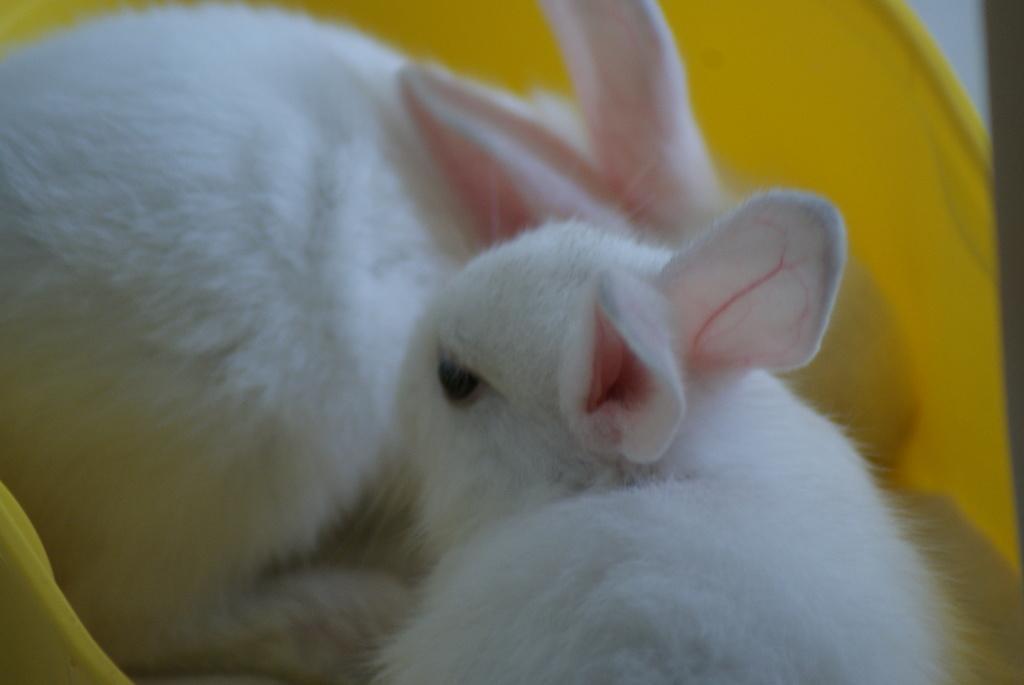Can you describe this image briefly? In this image I can see a yellow colored object and in the yellow colored object I can see two rabbits which are white, black and pink in color. 